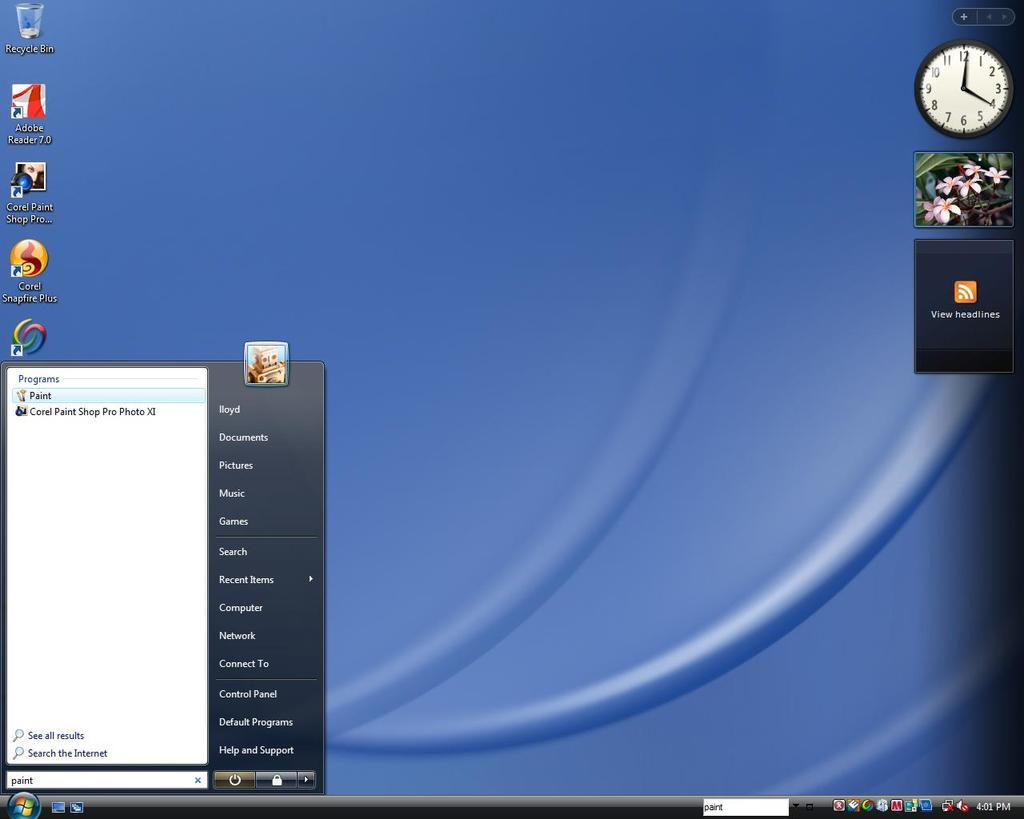Provide a one-sentence caption for the provided image. A Windows desktop screen with a blue background. 